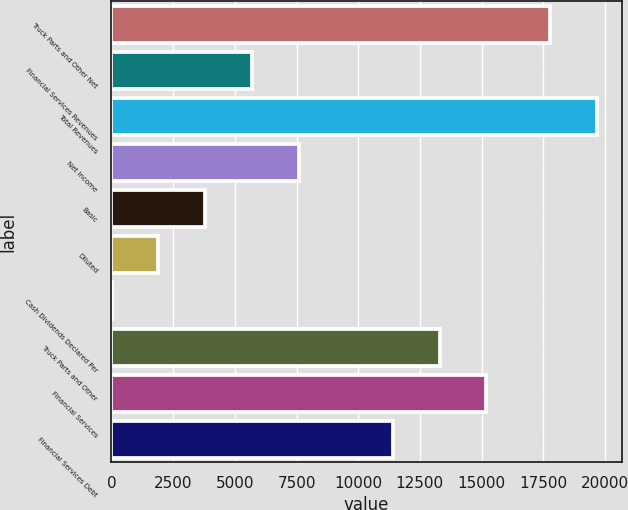<chart> <loc_0><loc_0><loc_500><loc_500><bar_chart><fcel>Truck Parts and Other Net<fcel>Financial Services Revenues<fcel>Total Revenues<fcel>Net Income<fcel>Basic<fcel>Diluted<fcel>Cash Dividends Declared Per<fcel>Truck Parts and Other<fcel>Financial Services<fcel>Financial Services Debt<nl><fcel>17792.8<fcel>5700.39<fcel>19692.3<fcel>7599.9<fcel>3800.88<fcel>1901.37<fcel>1.86<fcel>13298.4<fcel>15197.9<fcel>11398.9<nl></chart> 